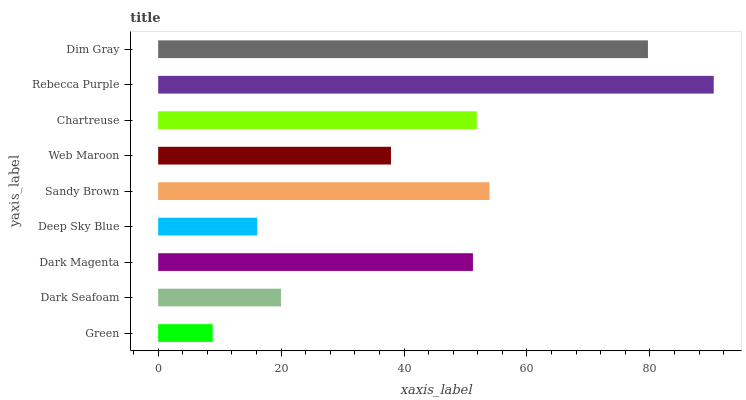Is Green the minimum?
Answer yes or no. Yes. Is Rebecca Purple the maximum?
Answer yes or no. Yes. Is Dark Seafoam the minimum?
Answer yes or no. No. Is Dark Seafoam the maximum?
Answer yes or no. No. Is Dark Seafoam greater than Green?
Answer yes or no. Yes. Is Green less than Dark Seafoam?
Answer yes or no. Yes. Is Green greater than Dark Seafoam?
Answer yes or no. No. Is Dark Seafoam less than Green?
Answer yes or no. No. Is Dark Magenta the high median?
Answer yes or no. Yes. Is Dark Magenta the low median?
Answer yes or no. Yes. Is Web Maroon the high median?
Answer yes or no. No. Is Dim Gray the low median?
Answer yes or no. No. 